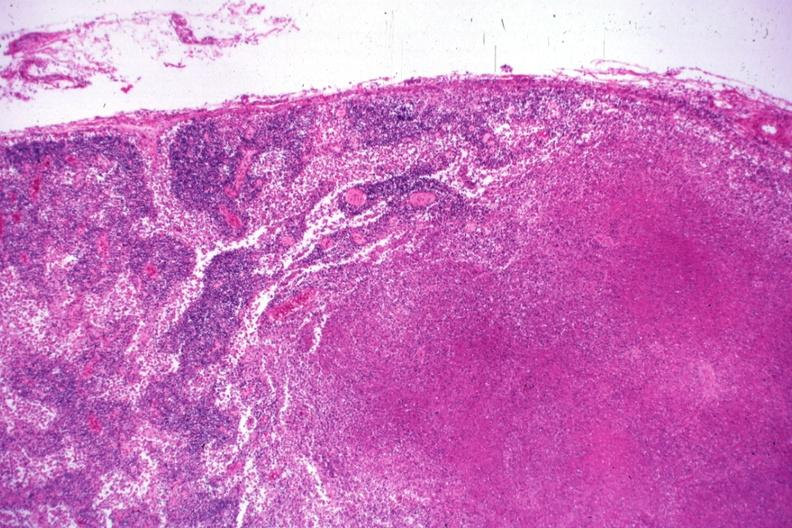what is present?
Answer the question using a single word or phrase. Lymph node 